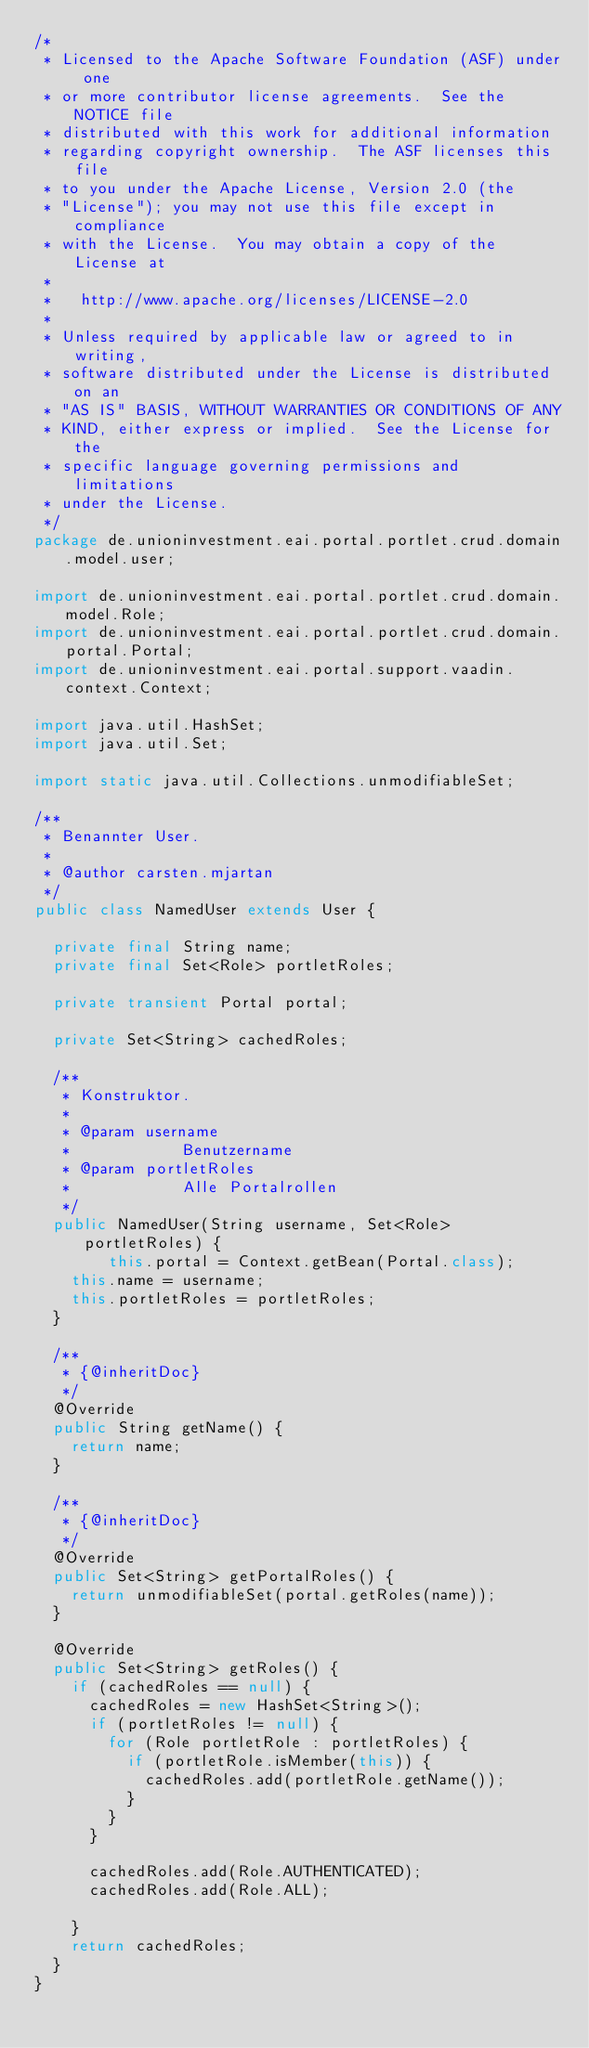Convert code to text. <code><loc_0><loc_0><loc_500><loc_500><_Java_>/*
 * Licensed to the Apache Software Foundation (ASF) under one
 * or more contributor license agreements.  See the NOTICE file
 * distributed with this work for additional information
 * regarding copyright ownership.  The ASF licenses this file
 * to you under the Apache License, Version 2.0 (the
 * "License"); you may not use this file except in compliance
 * with the License.  You may obtain a copy of the License at
 *
 *   http://www.apache.org/licenses/LICENSE-2.0
 *
 * Unless required by applicable law or agreed to in writing,
 * software distributed under the License is distributed on an
 * "AS IS" BASIS, WITHOUT WARRANTIES OR CONDITIONS OF ANY
 * KIND, either express or implied.  See the License for the
 * specific language governing permissions and limitations
 * under the License.
 */
package de.unioninvestment.eai.portal.portlet.crud.domain.model.user;

import de.unioninvestment.eai.portal.portlet.crud.domain.model.Role;
import de.unioninvestment.eai.portal.portlet.crud.domain.portal.Portal;
import de.unioninvestment.eai.portal.support.vaadin.context.Context;

import java.util.HashSet;
import java.util.Set;

import static java.util.Collections.unmodifiableSet;

/**
 * Benannter User.
 * 
 * @author carsten.mjartan
 */
public class NamedUser extends User {

	private final String name;
	private final Set<Role> portletRoles;

	private transient Portal portal;
	
	private Set<String> cachedRoles;

	/**
	 * Konstruktor.
	 * 
	 * @param username
	 *            Benutzername
	 * @param portletRoles
	 *            Alle Portalrollen
	 */
	public NamedUser(String username, Set<Role> portletRoles) {
        this.portal = Context.getBean(Portal.class);
		this.name = username;
		this.portletRoles = portletRoles;
	}

	/**
	 * {@inheritDoc}
	 */
	@Override
	public String getName() {
		return name;
	}

	/**
	 * {@inheritDoc}
	 */
	@Override
	public Set<String> getPortalRoles() {
		return unmodifiableSet(portal.getRoles(name));
	}

	@Override
	public Set<String> getRoles() {
		if (cachedRoles == null) {
			cachedRoles = new HashSet<String>();
			if (portletRoles != null) {
				for (Role portletRole : portletRoles) {
					if (portletRole.isMember(this)) {
						cachedRoles.add(portletRole.getName());
					}
				}
			}

			cachedRoles.add(Role.AUTHENTICATED);
			cachedRoles.add(Role.ALL);

		}
		return cachedRoles;
	}
}
</code> 